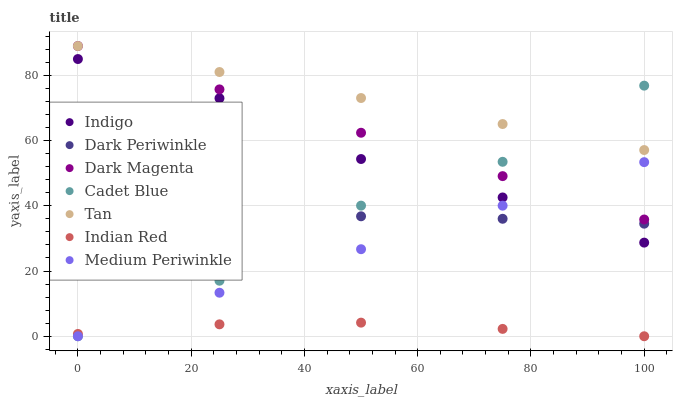Does Indian Red have the minimum area under the curve?
Answer yes or no. Yes. Does Tan have the maximum area under the curve?
Answer yes or no. Yes. Does Indigo have the minimum area under the curve?
Answer yes or no. No. Does Indigo have the maximum area under the curve?
Answer yes or no. No. Is Dark Magenta the smoothest?
Answer yes or no. Yes. Is Cadet Blue the roughest?
Answer yes or no. Yes. Is Indigo the smoothest?
Answer yes or no. No. Is Indigo the roughest?
Answer yes or no. No. Does Cadet Blue have the lowest value?
Answer yes or no. Yes. Does Indigo have the lowest value?
Answer yes or no. No. Does Tan have the highest value?
Answer yes or no. Yes. Does Indigo have the highest value?
Answer yes or no. No. Is Indian Red less than Indigo?
Answer yes or no. Yes. Is Indigo greater than Indian Red?
Answer yes or no. Yes. Does Tan intersect Dark Magenta?
Answer yes or no. Yes. Is Tan less than Dark Magenta?
Answer yes or no. No. Is Tan greater than Dark Magenta?
Answer yes or no. No. Does Indian Red intersect Indigo?
Answer yes or no. No. 